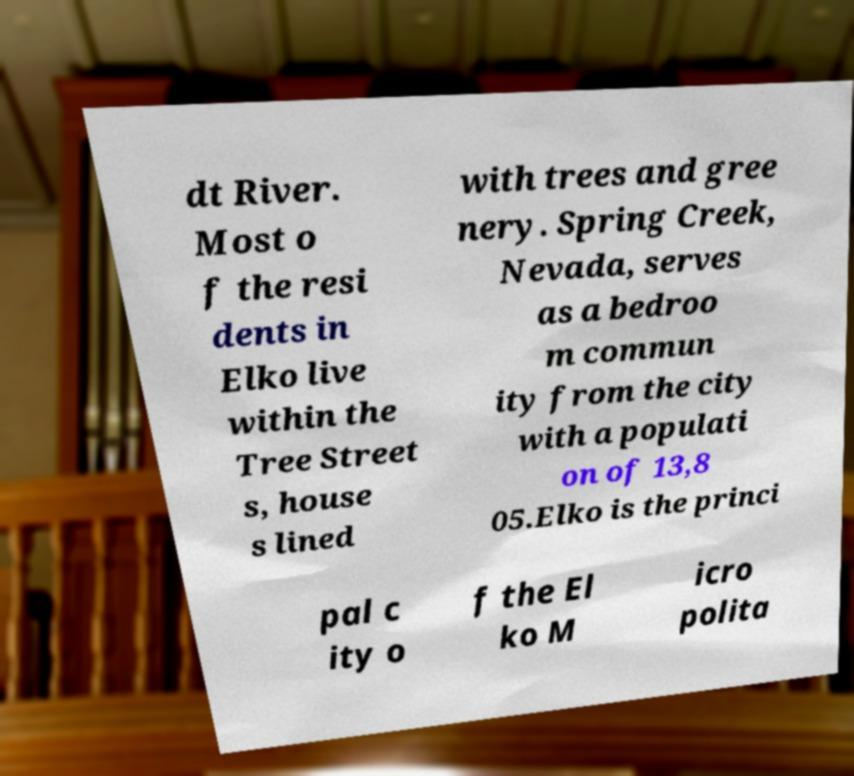For documentation purposes, I need the text within this image transcribed. Could you provide that? dt River. Most o f the resi dents in Elko live within the Tree Street s, house s lined with trees and gree nery. Spring Creek, Nevada, serves as a bedroo m commun ity from the city with a populati on of 13,8 05.Elko is the princi pal c ity o f the El ko M icro polita 